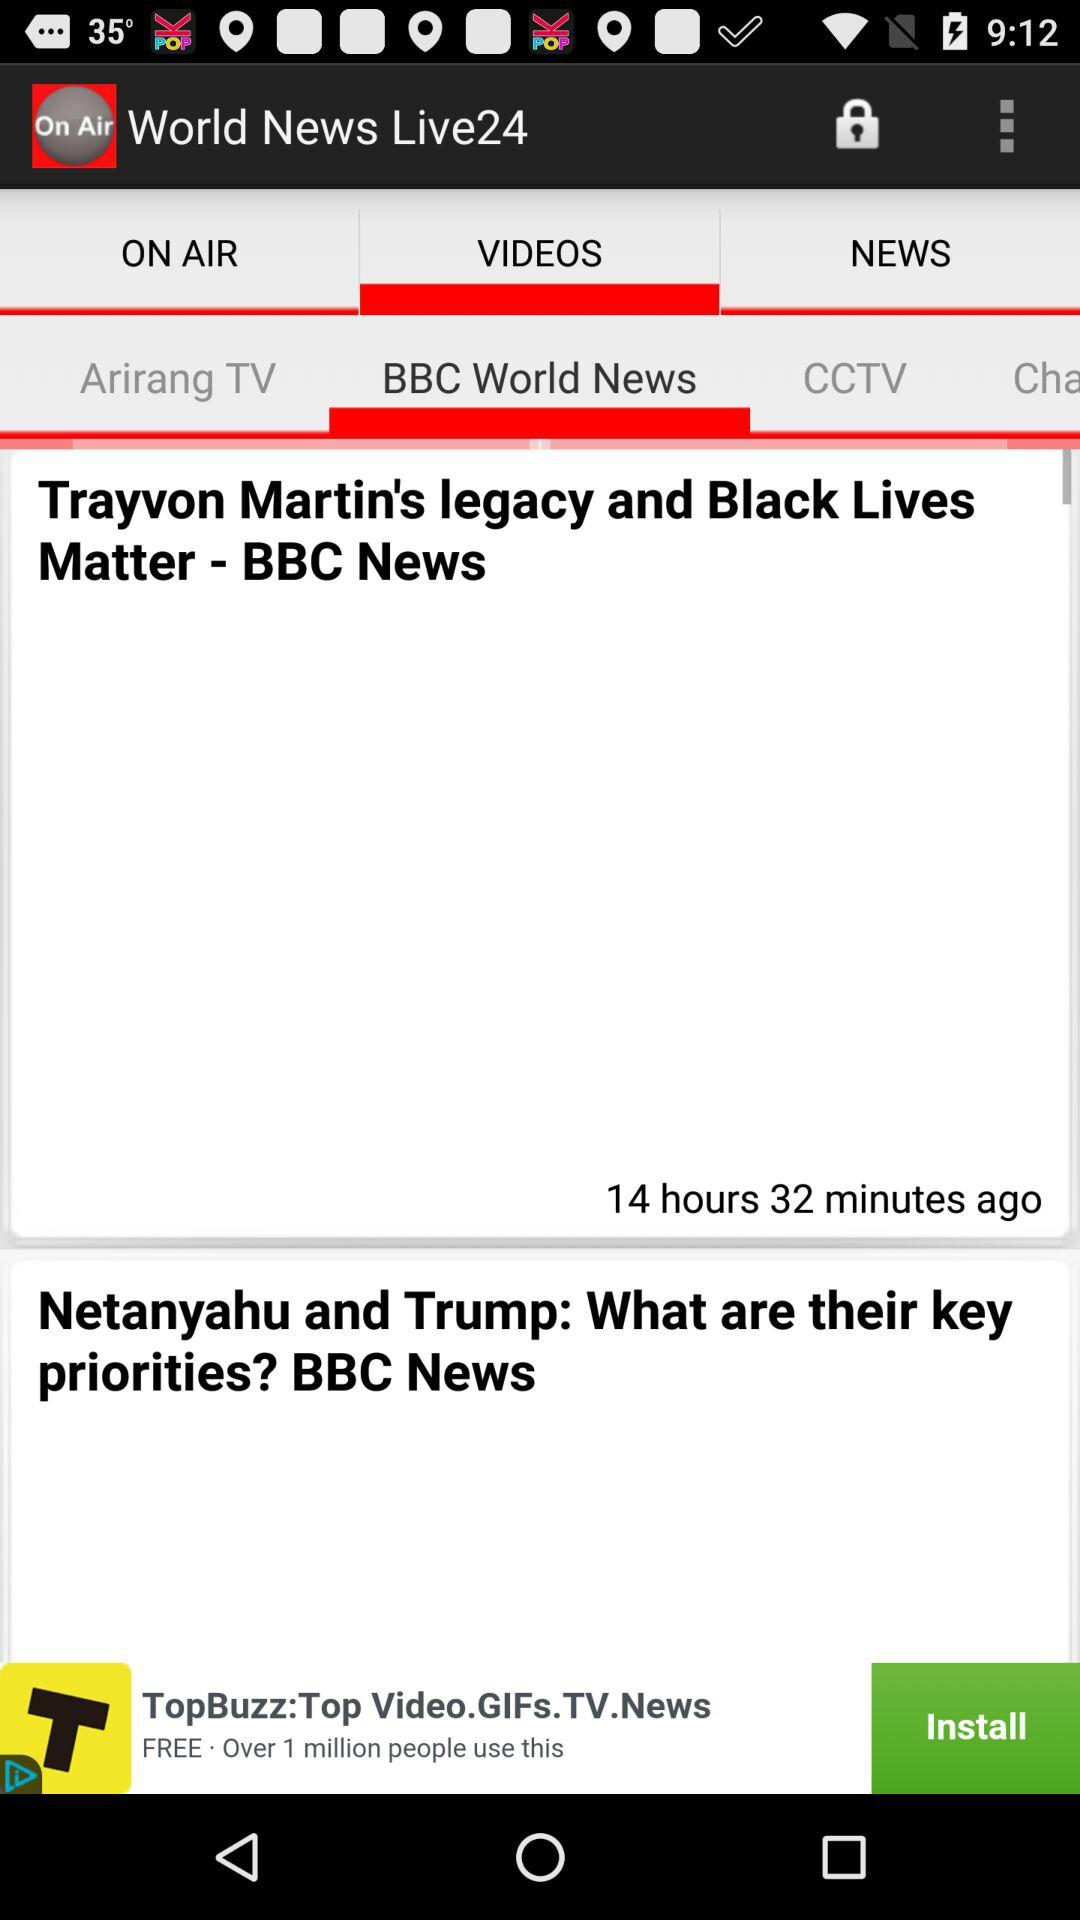When was the news about "Trayvon Martin's Legacy" published? The news was published 14 hours and 32 minutes ago. 